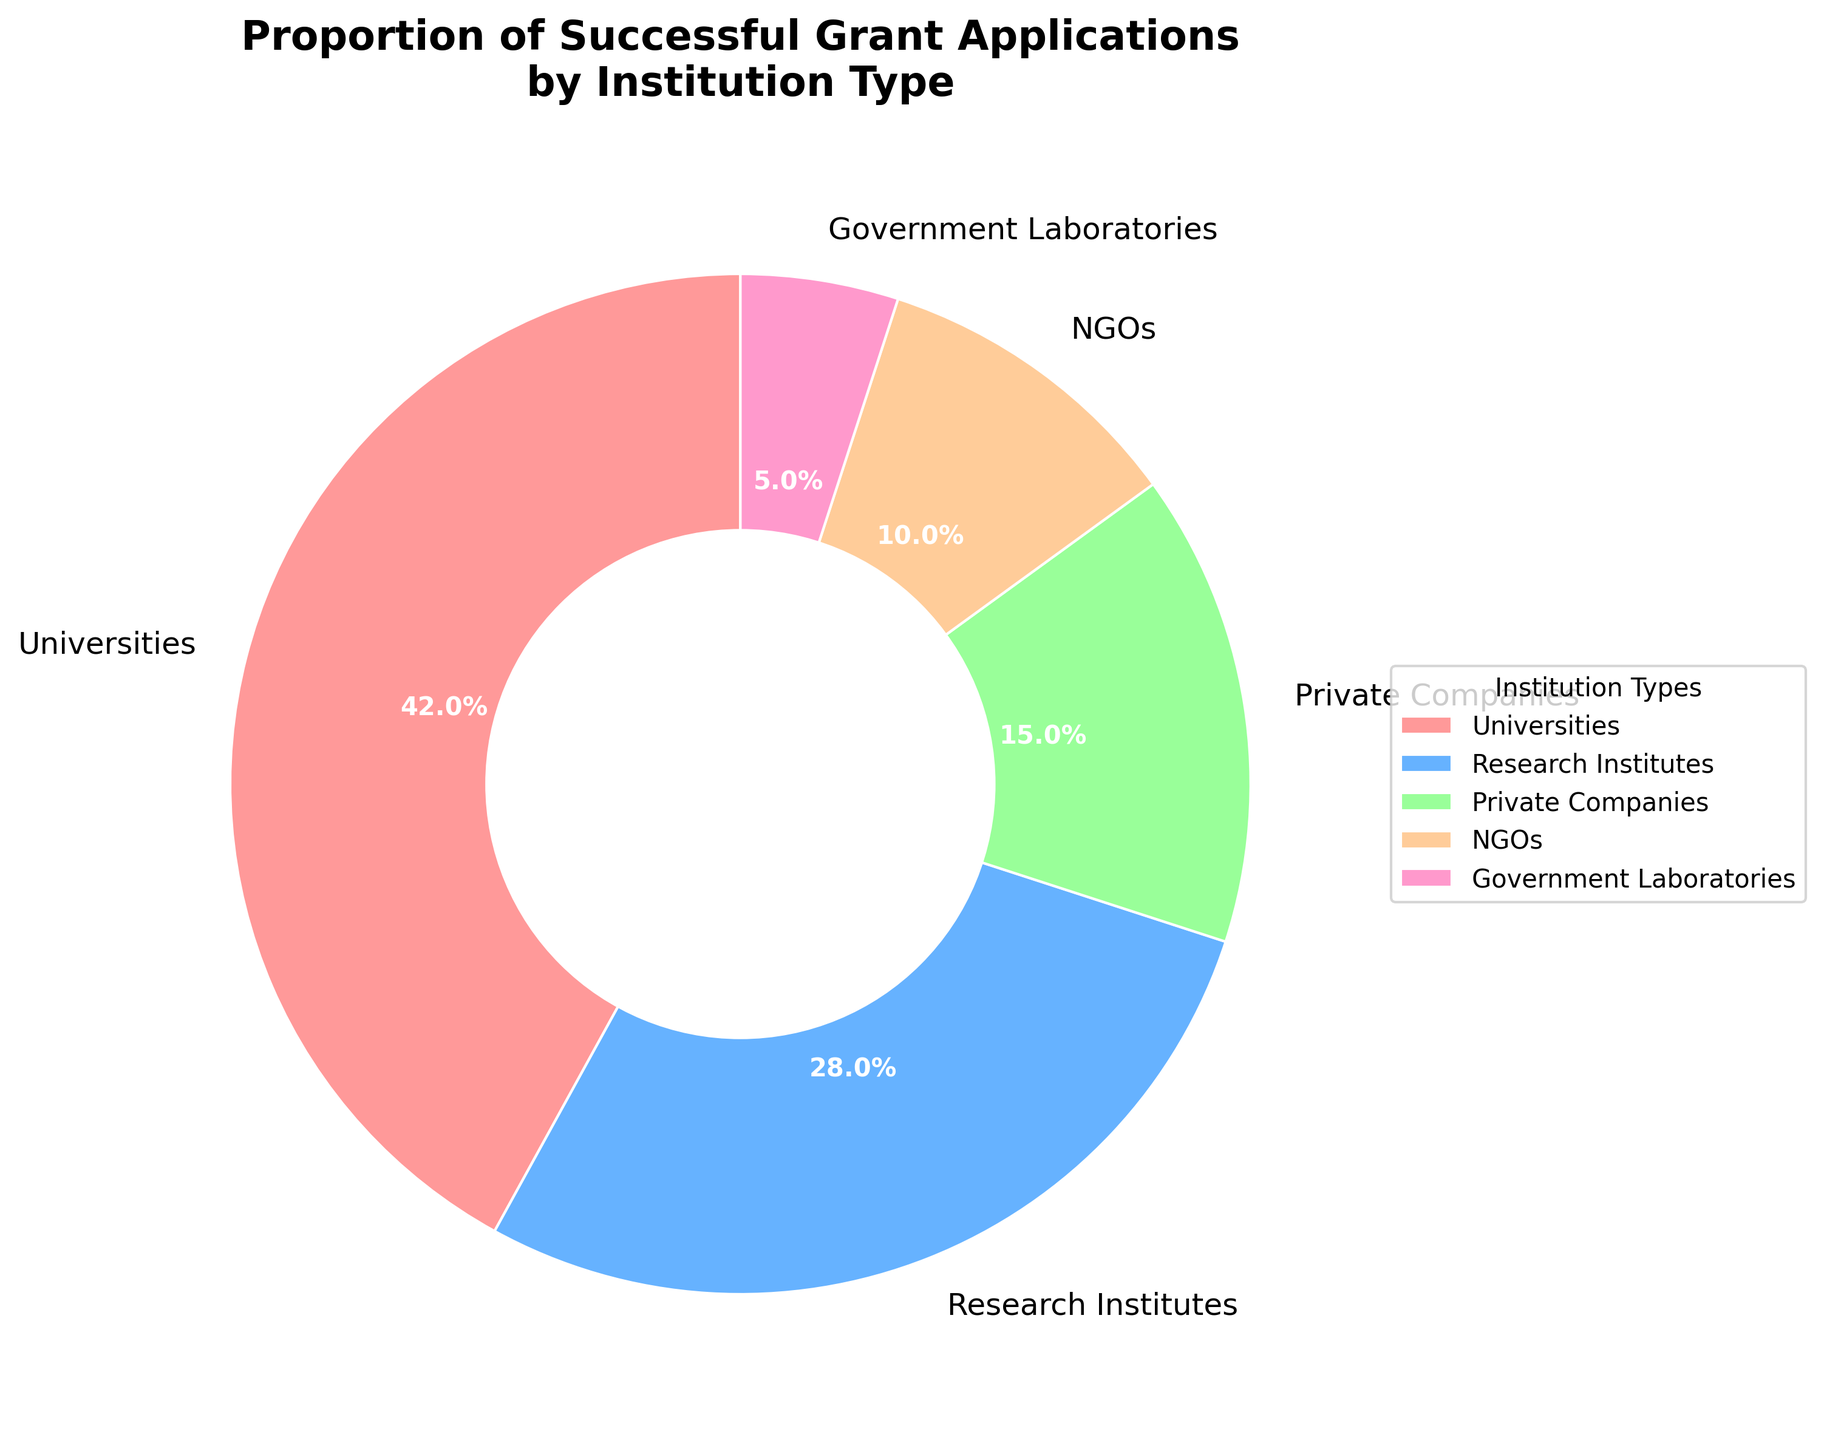Which institution type has the highest proportion of successful grant applications? From the pie chart, the largest segment is labeled "Universities." This indicates that universities have the highest proportion.
Answer: Universities Which two institution types together account for more than half of the successful grant applications? Summing the proportions of the two largest segments, "Universities" (42%) and "Research Institutes" (28%), gives 42% + 28% = 70%, which is more than half.
Answer: Universities and Research Institutes How much higher is the proportion of successful grant applications for Universities compared to NGOs? The proportion for Universities is 42% and for NGOs is 10%. The difference is 42% - 10% = 32%.
Answer: 32% Which institution type has the lowest proportion of successful grant applications? The smallest segment in the pie chart is labeled "Government Laboratories," indicating they have the lowest proportion.
Answer: Government Laboratories Are the proportions of successful grant applications for Private Companies and NGOs combined higher than the proportion for Research Institutes? Adding the proportions of Private Companies (15%) and NGOs (10%) gives 15% + 10% = 25%, which is less than the proportion for Research Institutes (28%).
Answer: No Which visual attribute would help to quickly identify the institution type with the smallest proportion of successful grant applications? The smallest sector is visually distinct because of its minimal size relative to the other sectors.
Answer: The smallest sector What is the average proportion of successful grant applications across University, Research Institutes, and Private Companies? Adding the proportions of Universities (42%), Research Institutes (28%), and Private Companies (15%) equals 85%. The average is 85% / 3 = 28.33%.
Answer: 28.33% How many more percentage points is the proportion of successful grant applications for Research Institutes compared to Government Laboratories? The proportion for Research Institutes is 28% and for Government Laboratories is 5%. The difference is 28% - 5% = 23 percentage points.
Answer: 23 percentage points If the proportion of successful grants for NGOs increased by 5 percentage points, how would this new value compare to the current proportion for Private Companies? The current proportion for NGOs is 10%. Increasing this by 5 percentage points results in 15%, which is equal to the proportion for Private Companies (15%).
Answer: Equal 